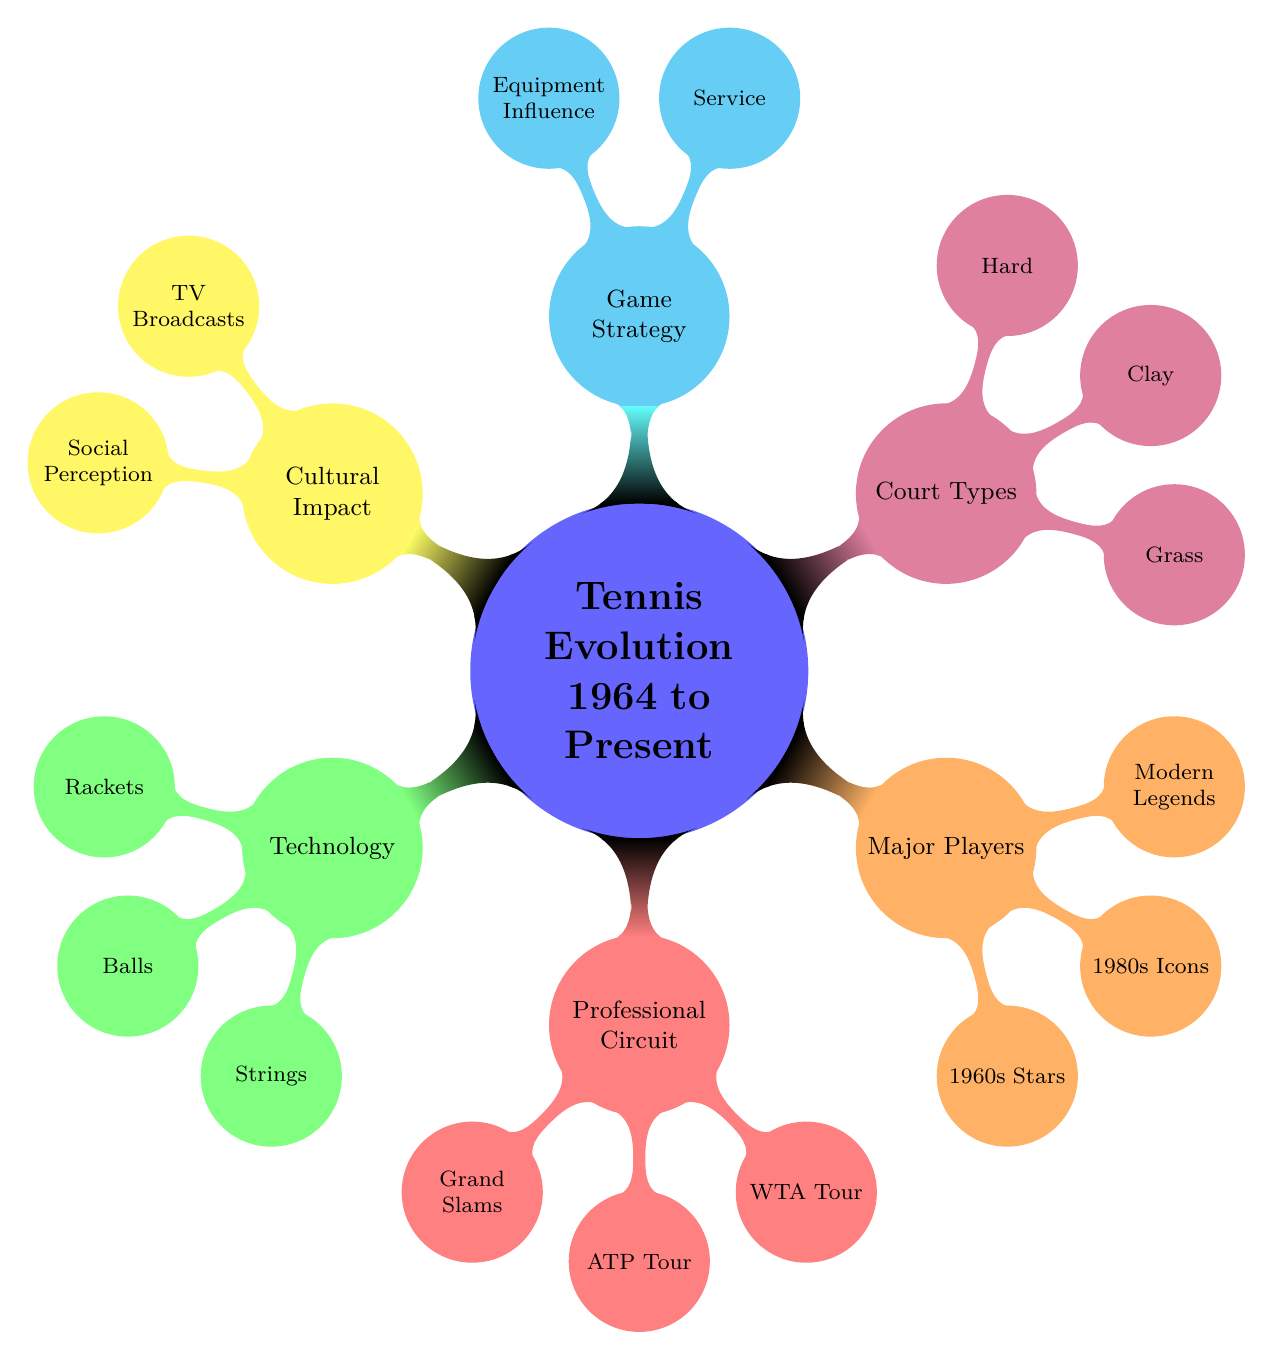What are the types of rackets mentioned? The diagram lists three main types of rackets under the Technology category: Wood to Composite Materials, Graphite Rackets Introduction (1980s), and Modern Carbon Fiber Rackets.
Answer: Wood to Composite Materials, Graphite Rackets Introduction (1980s), Modern Carbon Fiber Rackets Which major players are in the 1980s Icons category? The 1980s Icons category in the Major Players section includes Björn Borg, John McEnroe, and Martina Navratilova, as indicated in the diagram.
Answer: Björn Borg, John McEnroe, Martina Navratilova How many Grand Slams are listed? The diagram shows four Grand Slams under the Professional Circuit section: Wimbledon, US Open, French Open, and Australian Open. Thus, the count is four.
Answer: 4 What is the primary strategy shift mentioned in Game Strategy? The diagram indicates a shift from Serve-and-Volley (1960s) to Baseline Power Play as a primary game strategy in the modern era.
Answer: Baseline Power Play Which type of court is associated with the French Open? The diagram links the French Open with the Clay court type, noting its dominance and slow surface characteristics.
Answer: Clay What impact did the formation of ATP and WTA have? Both the ATP (1972) and WTA (1973) signify the establishment of professional circuits, leading to a more organized structure in men's and women's tennis, thereby contributing to equal prize money achievements.
Answer: Equal Prize Money Achievements What is a cultural impact of tennis since 1964? The diagram notes the cultural impact of tennis includes the advent of first live broadcasts, leading to global audiences, as shown in the Cultural Impact section.
Answer: First Live Broadcasts, Global Audiences What are the historical surface preferences indicated for Grass courts? Under the Grass court type, the diagram highlights Wimbledon and mentions the historical surface preference for players, which has been critical in shaping the playing style over the years.
Answer: Wimbledon, Historical Surface Preference 